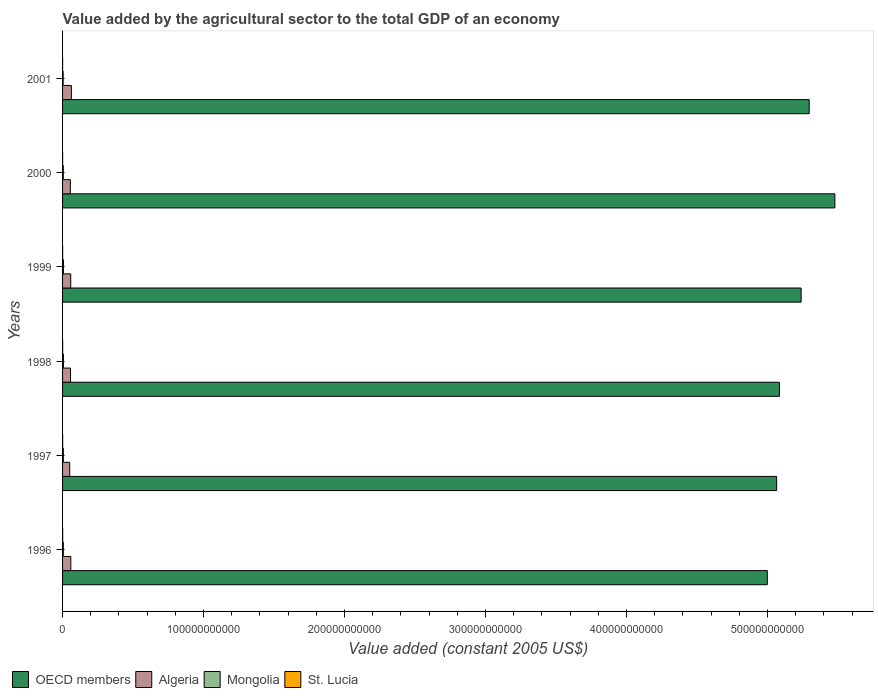How many bars are there on the 1st tick from the top?
Keep it short and to the point. 4. How many bars are there on the 4th tick from the bottom?
Provide a succinct answer. 4. What is the label of the 6th group of bars from the top?
Your answer should be very brief. 1996. What is the value added by the agricultural sector in OECD members in 1996?
Your answer should be compact. 5.00e+11. Across all years, what is the maximum value added by the agricultural sector in St. Lucia?
Your response must be concise. 8.23e+07. Across all years, what is the minimum value added by the agricultural sector in St. Lucia?
Give a very brief answer. 3.62e+07. What is the total value added by the agricultural sector in Algeria in the graph?
Your response must be concise. 3.41e+1. What is the difference between the value added by the agricultural sector in St. Lucia in 1997 and that in 2001?
Offer a terse response. 3.11e+07. What is the difference between the value added by the agricultural sector in Algeria in 1998 and the value added by the agricultural sector in Mongolia in 2001?
Keep it short and to the point. 5.23e+09. What is the average value added by the agricultural sector in Mongolia per year?
Ensure brevity in your answer.  5.40e+08. In the year 2001, what is the difference between the value added by the agricultural sector in Mongolia and value added by the agricultural sector in OECD members?
Ensure brevity in your answer.  -5.29e+11. In how many years, is the value added by the agricultural sector in Algeria greater than 440000000000 US$?
Your answer should be very brief. 0. What is the ratio of the value added by the agricultural sector in Algeria in 1998 to that in 1999?
Provide a short and direct response. 0.97. Is the difference between the value added by the agricultural sector in Mongolia in 1997 and 1999 greater than the difference between the value added by the agricultural sector in OECD members in 1997 and 1999?
Your answer should be compact. Yes. What is the difference between the highest and the second highest value added by the agricultural sector in St. Lucia?
Your answer should be very brief. 1.50e+07. What is the difference between the highest and the lowest value added by the agricultural sector in St. Lucia?
Your response must be concise. 4.61e+07. Is the sum of the value added by the agricultural sector in Algeria in 1996 and 1998 greater than the maximum value added by the agricultural sector in OECD members across all years?
Ensure brevity in your answer.  No. Is it the case that in every year, the sum of the value added by the agricultural sector in Mongolia and value added by the agricultural sector in Algeria is greater than the sum of value added by the agricultural sector in OECD members and value added by the agricultural sector in St. Lucia?
Provide a succinct answer. No. What does the 4th bar from the top in 1997 represents?
Ensure brevity in your answer.  OECD members. How many bars are there?
Make the answer very short. 24. Are all the bars in the graph horizontal?
Offer a very short reply. Yes. What is the difference between two consecutive major ticks on the X-axis?
Make the answer very short. 1.00e+11. Does the graph contain any zero values?
Your answer should be very brief. No. How many legend labels are there?
Make the answer very short. 4. How are the legend labels stacked?
Provide a short and direct response. Horizontal. What is the title of the graph?
Make the answer very short. Value added by the agricultural sector to the total GDP of an economy. Does "Trinidad and Tobago" appear as one of the legend labels in the graph?
Give a very brief answer. No. What is the label or title of the X-axis?
Provide a short and direct response. Value added (constant 2005 US$). What is the label or title of the Y-axis?
Keep it short and to the point. Years. What is the Value added (constant 2005 US$) in OECD members in 1996?
Your answer should be compact. 5.00e+11. What is the Value added (constant 2005 US$) in Algeria in 1996?
Your answer should be compact. 5.85e+09. What is the Value added (constant 2005 US$) in Mongolia in 1996?
Give a very brief answer. 5.42e+08. What is the Value added (constant 2005 US$) of St. Lucia in 1996?
Give a very brief answer. 8.23e+07. What is the Value added (constant 2005 US$) in OECD members in 1997?
Provide a succinct answer. 5.06e+11. What is the Value added (constant 2005 US$) in Algeria in 1997?
Give a very brief answer. 5.06e+09. What is the Value added (constant 2005 US$) in Mongolia in 1997?
Give a very brief answer. 5.66e+08. What is the Value added (constant 2005 US$) in St. Lucia in 1997?
Give a very brief answer. 6.73e+07. What is the Value added (constant 2005 US$) in OECD members in 1998?
Ensure brevity in your answer.  5.08e+11. What is the Value added (constant 2005 US$) in Algeria in 1998?
Make the answer very short. 5.64e+09. What is the Value added (constant 2005 US$) in Mongolia in 1998?
Offer a terse response. 5.95e+08. What is the Value added (constant 2005 US$) in St. Lucia in 1998?
Keep it short and to the point. 6.65e+07. What is the Value added (constant 2005 US$) of OECD members in 1999?
Keep it short and to the point. 5.24e+11. What is the Value added (constant 2005 US$) of Algeria in 1999?
Ensure brevity in your answer.  5.79e+09. What is the Value added (constant 2005 US$) in Mongolia in 1999?
Keep it short and to the point. 6.12e+08. What is the Value added (constant 2005 US$) in St. Lucia in 1999?
Give a very brief answer. 5.66e+07. What is the Value added (constant 2005 US$) of OECD members in 2000?
Your answer should be compact. 5.48e+11. What is the Value added (constant 2005 US$) in Algeria in 2000?
Give a very brief answer. 5.50e+09. What is the Value added (constant 2005 US$) of Mongolia in 2000?
Provide a short and direct response. 5.12e+08. What is the Value added (constant 2005 US$) in St. Lucia in 2000?
Make the answer very short. 4.70e+07. What is the Value added (constant 2005 US$) in OECD members in 2001?
Keep it short and to the point. 5.30e+11. What is the Value added (constant 2005 US$) in Algeria in 2001?
Ensure brevity in your answer.  6.23e+09. What is the Value added (constant 2005 US$) in Mongolia in 2001?
Provide a short and direct response. 4.14e+08. What is the Value added (constant 2005 US$) of St. Lucia in 2001?
Provide a succinct answer. 3.62e+07. Across all years, what is the maximum Value added (constant 2005 US$) in OECD members?
Your answer should be compact. 5.48e+11. Across all years, what is the maximum Value added (constant 2005 US$) in Algeria?
Provide a short and direct response. 6.23e+09. Across all years, what is the maximum Value added (constant 2005 US$) in Mongolia?
Make the answer very short. 6.12e+08. Across all years, what is the maximum Value added (constant 2005 US$) of St. Lucia?
Give a very brief answer. 8.23e+07. Across all years, what is the minimum Value added (constant 2005 US$) of OECD members?
Your answer should be compact. 5.00e+11. Across all years, what is the minimum Value added (constant 2005 US$) in Algeria?
Make the answer very short. 5.06e+09. Across all years, what is the minimum Value added (constant 2005 US$) of Mongolia?
Keep it short and to the point. 4.14e+08. Across all years, what is the minimum Value added (constant 2005 US$) of St. Lucia?
Keep it short and to the point. 3.62e+07. What is the total Value added (constant 2005 US$) in OECD members in the graph?
Provide a short and direct response. 3.12e+12. What is the total Value added (constant 2005 US$) in Algeria in the graph?
Offer a very short reply. 3.41e+1. What is the total Value added (constant 2005 US$) of Mongolia in the graph?
Offer a terse response. 3.24e+09. What is the total Value added (constant 2005 US$) in St. Lucia in the graph?
Your answer should be compact. 3.56e+08. What is the difference between the Value added (constant 2005 US$) of OECD members in 1996 and that in 1997?
Keep it short and to the point. -6.63e+09. What is the difference between the Value added (constant 2005 US$) in Algeria in 1996 and that in 1997?
Give a very brief answer. 7.87e+08. What is the difference between the Value added (constant 2005 US$) of Mongolia in 1996 and that in 1997?
Give a very brief answer. -2.40e+07. What is the difference between the Value added (constant 2005 US$) of St. Lucia in 1996 and that in 1997?
Give a very brief answer. 1.50e+07. What is the difference between the Value added (constant 2005 US$) in OECD members in 1996 and that in 1998?
Provide a short and direct response. -8.59e+09. What is the difference between the Value added (constant 2005 US$) in Algeria in 1996 and that in 1998?
Keep it short and to the point. 2.10e+08. What is the difference between the Value added (constant 2005 US$) of Mongolia in 1996 and that in 1998?
Give a very brief answer. -5.32e+07. What is the difference between the Value added (constant 2005 US$) of St. Lucia in 1996 and that in 1998?
Provide a short and direct response. 1.58e+07. What is the difference between the Value added (constant 2005 US$) in OECD members in 1996 and that in 1999?
Offer a terse response. -2.40e+1. What is the difference between the Value added (constant 2005 US$) in Algeria in 1996 and that in 1999?
Keep it short and to the point. 5.73e+07. What is the difference between the Value added (constant 2005 US$) of Mongolia in 1996 and that in 1999?
Provide a succinct answer. -7.03e+07. What is the difference between the Value added (constant 2005 US$) of St. Lucia in 1996 and that in 1999?
Keep it short and to the point. 2.57e+07. What is the difference between the Value added (constant 2005 US$) in OECD members in 1996 and that in 2000?
Make the answer very short. -4.79e+1. What is the difference between the Value added (constant 2005 US$) in Algeria in 1996 and that in 2000?
Your answer should be compact. 3.47e+08. What is the difference between the Value added (constant 2005 US$) of Mongolia in 1996 and that in 2000?
Ensure brevity in your answer.  2.97e+07. What is the difference between the Value added (constant 2005 US$) in St. Lucia in 1996 and that in 2000?
Offer a very short reply. 3.53e+07. What is the difference between the Value added (constant 2005 US$) of OECD members in 1996 and that in 2001?
Provide a succinct answer. -2.97e+1. What is the difference between the Value added (constant 2005 US$) in Algeria in 1996 and that in 2001?
Give a very brief answer. -3.84e+08. What is the difference between the Value added (constant 2005 US$) of Mongolia in 1996 and that in 2001?
Ensure brevity in your answer.  1.28e+08. What is the difference between the Value added (constant 2005 US$) of St. Lucia in 1996 and that in 2001?
Offer a terse response. 4.61e+07. What is the difference between the Value added (constant 2005 US$) of OECD members in 1997 and that in 1998?
Make the answer very short. -1.96e+09. What is the difference between the Value added (constant 2005 US$) of Algeria in 1997 and that in 1998?
Your answer should be compact. -5.77e+08. What is the difference between the Value added (constant 2005 US$) in Mongolia in 1997 and that in 1998?
Your response must be concise. -2.92e+07. What is the difference between the Value added (constant 2005 US$) in St. Lucia in 1997 and that in 1998?
Offer a terse response. 8.07e+05. What is the difference between the Value added (constant 2005 US$) of OECD members in 1997 and that in 1999?
Provide a succinct answer. -1.74e+1. What is the difference between the Value added (constant 2005 US$) of Algeria in 1997 and that in 1999?
Provide a short and direct response. -7.30e+08. What is the difference between the Value added (constant 2005 US$) in Mongolia in 1997 and that in 1999?
Keep it short and to the point. -4.63e+07. What is the difference between the Value added (constant 2005 US$) in St. Lucia in 1997 and that in 1999?
Keep it short and to the point. 1.07e+07. What is the difference between the Value added (constant 2005 US$) in OECD members in 1997 and that in 2000?
Provide a short and direct response. -4.13e+1. What is the difference between the Value added (constant 2005 US$) in Algeria in 1997 and that in 2000?
Make the answer very short. -4.40e+08. What is the difference between the Value added (constant 2005 US$) in Mongolia in 1997 and that in 2000?
Offer a terse response. 5.37e+07. What is the difference between the Value added (constant 2005 US$) in St. Lucia in 1997 and that in 2000?
Your answer should be compact. 2.03e+07. What is the difference between the Value added (constant 2005 US$) in OECD members in 1997 and that in 2001?
Ensure brevity in your answer.  -2.31e+1. What is the difference between the Value added (constant 2005 US$) in Algeria in 1997 and that in 2001?
Your answer should be compact. -1.17e+09. What is the difference between the Value added (constant 2005 US$) of Mongolia in 1997 and that in 2001?
Offer a terse response. 1.52e+08. What is the difference between the Value added (constant 2005 US$) of St. Lucia in 1997 and that in 2001?
Keep it short and to the point. 3.11e+07. What is the difference between the Value added (constant 2005 US$) in OECD members in 1998 and that in 1999?
Provide a short and direct response. -1.54e+1. What is the difference between the Value added (constant 2005 US$) in Algeria in 1998 and that in 1999?
Provide a succinct answer. -1.52e+08. What is the difference between the Value added (constant 2005 US$) in Mongolia in 1998 and that in 1999?
Provide a succinct answer. -1.70e+07. What is the difference between the Value added (constant 2005 US$) of St. Lucia in 1998 and that in 1999?
Your answer should be very brief. 9.93e+06. What is the difference between the Value added (constant 2005 US$) of OECD members in 1998 and that in 2000?
Provide a succinct answer. -3.93e+1. What is the difference between the Value added (constant 2005 US$) of Algeria in 1998 and that in 2000?
Provide a short and direct response. 1.37e+08. What is the difference between the Value added (constant 2005 US$) in Mongolia in 1998 and that in 2000?
Give a very brief answer. 8.29e+07. What is the difference between the Value added (constant 2005 US$) of St. Lucia in 1998 and that in 2000?
Your response must be concise. 1.95e+07. What is the difference between the Value added (constant 2005 US$) of OECD members in 1998 and that in 2001?
Offer a terse response. -2.11e+1. What is the difference between the Value added (constant 2005 US$) in Algeria in 1998 and that in 2001?
Keep it short and to the point. -5.93e+08. What is the difference between the Value added (constant 2005 US$) in Mongolia in 1998 and that in 2001?
Make the answer very short. 1.81e+08. What is the difference between the Value added (constant 2005 US$) in St. Lucia in 1998 and that in 2001?
Give a very brief answer. 3.03e+07. What is the difference between the Value added (constant 2005 US$) in OECD members in 1999 and that in 2000?
Provide a short and direct response. -2.39e+1. What is the difference between the Value added (constant 2005 US$) in Algeria in 1999 and that in 2000?
Your answer should be very brief. 2.90e+08. What is the difference between the Value added (constant 2005 US$) in Mongolia in 1999 and that in 2000?
Keep it short and to the point. 1.00e+08. What is the difference between the Value added (constant 2005 US$) of St. Lucia in 1999 and that in 2000?
Your answer should be very brief. 9.55e+06. What is the difference between the Value added (constant 2005 US$) in OECD members in 1999 and that in 2001?
Offer a very short reply. -5.73e+09. What is the difference between the Value added (constant 2005 US$) of Algeria in 1999 and that in 2001?
Keep it short and to the point. -4.41e+08. What is the difference between the Value added (constant 2005 US$) of Mongolia in 1999 and that in 2001?
Offer a very short reply. 1.98e+08. What is the difference between the Value added (constant 2005 US$) of St. Lucia in 1999 and that in 2001?
Give a very brief answer. 2.04e+07. What is the difference between the Value added (constant 2005 US$) in OECD members in 2000 and that in 2001?
Your answer should be very brief. 1.82e+1. What is the difference between the Value added (constant 2005 US$) in Algeria in 2000 and that in 2001?
Provide a succinct answer. -7.31e+08. What is the difference between the Value added (constant 2005 US$) in Mongolia in 2000 and that in 2001?
Offer a very short reply. 9.81e+07. What is the difference between the Value added (constant 2005 US$) of St. Lucia in 2000 and that in 2001?
Ensure brevity in your answer.  1.08e+07. What is the difference between the Value added (constant 2005 US$) of OECD members in 1996 and the Value added (constant 2005 US$) of Algeria in 1997?
Give a very brief answer. 4.95e+11. What is the difference between the Value added (constant 2005 US$) of OECD members in 1996 and the Value added (constant 2005 US$) of Mongolia in 1997?
Keep it short and to the point. 4.99e+11. What is the difference between the Value added (constant 2005 US$) of OECD members in 1996 and the Value added (constant 2005 US$) of St. Lucia in 1997?
Provide a short and direct response. 5.00e+11. What is the difference between the Value added (constant 2005 US$) in Algeria in 1996 and the Value added (constant 2005 US$) in Mongolia in 1997?
Provide a succinct answer. 5.29e+09. What is the difference between the Value added (constant 2005 US$) of Algeria in 1996 and the Value added (constant 2005 US$) of St. Lucia in 1997?
Provide a short and direct response. 5.78e+09. What is the difference between the Value added (constant 2005 US$) in Mongolia in 1996 and the Value added (constant 2005 US$) in St. Lucia in 1997?
Offer a terse response. 4.75e+08. What is the difference between the Value added (constant 2005 US$) of OECD members in 1996 and the Value added (constant 2005 US$) of Algeria in 1998?
Make the answer very short. 4.94e+11. What is the difference between the Value added (constant 2005 US$) of OECD members in 1996 and the Value added (constant 2005 US$) of Mongolia in 1998?
Give a very brief answer. 4.99e+11. What is the difference between the Value added (constant 2005 US$) of OECD members in 1996 and the Value added (constant 2005 US$) of St. Lucia in 1998?
Provide a short and direct response. 5.00e+11. What is the difference between the Value added (constant 2005 US$) in Algeria in 1996 and the Value added (constant 2005 US$) in Mongolia in 1998?
Keep it short and to the point. 5.26e+09. What is the difference between the Value added (constant 2005 US$) in Algeria in 1996 and the Value added (constant 2005 US$) in St. Lucia in 1998?
Give a very brief answer. 5.78e+09. What is the difference between the Value added (constant 2005 US$) of Mongolia in 1996 and the Value added (constant 2005 US$) of St. Lucia in 1998?
Ensure brevity in your answer.  4.75e+08. What is the difference between the Value added (constant 2005 US$) of OECD members in 1996 and the Value added (constant 2005 US$) of Algeria in 1999?
Give a very brief answer. 4.94e+11. What is the difference between the Value added (constant 2005 US$) of OECD members in 1996 and the Value added (constant 2005 US$) of Mongolia in 1999?
Give a very brief answer. 4.99e+11. What is the difference between the Value added (constant 2005 US$) in OECD members in 1996 and the Value added (constant 2005 US$) in St. Lucia in 1999?
Keep it short and to the point. 5.00e+11. What is the difference between the Value added (constant 2005 US$) in Algeria in 1996 and the Value added (constant 2005 US$) in Mongolia in 1999?
Offer a terse response. 5.24e+09. What is the difference between the Value added (constant 2005 US$) of Algeria in 1996 and the Value added (constant 2005 US$) of St. Lucia in 1999?
Offer a terse response. 5.79e+09. What is the difference between the Value added (constant 2005 US$) of Mongolia in 1996 and the Value added (constant 2005 US$) of St. Lucia in 1999?
Offer a very short reply. 4.85e+08. What is the difference between the Value added (constant 2005 US$) of OECD members in 1996 and the Value added (constant 2005 US$) of Algeria in 2000?
Offer a terse response. 4.94e+11. What is the difference between the Value added (constant 2005 US$) of OECD members in 1996 and the Value added (constant 2005 US$) of Mongolia in 2000?
Provide a short and direct response. 4.99e+11. What is the difference between the Value added (constant 2005 US$) of OECD members in 1996 and the Value added (constant 2005 US$) of St. Lucia in 2000?
Offer a very short reply. 5.00e+11. What is the difference between the Value added (constant 2005 US$) in Algeria in 1996 and the Value added (constant 2005 US$) in Mongolia in 2000?
Your answer should be very brief. 5.34e+09. What is the difference between the Value added (constant 2005 US$) of Algeria in 1996 and the Value added (constant 2005 US$) of St. Lucia in 2000?
Your response must be concise. 5.80e+09. What is the difference between the Value added (constant 2005 US$) of Mongolia in 1996 and the Value added (constant 2005 US$) of St. Lucia in 2000?
Offer a very short reply. 4.95e+08. What is the difference between the Value added (constant 2005 US$) in OECD members in 1996 and the Value added (constant 2005 US$) in Algeria in 2001?
Offer a very short reply. 4.94e+11. What is the difference between the Value added (constant 2005 US$) of OECD members in 1996 and the Value added (constant 2005 US$) of Mongolia in 2001?
Offer a terse response. 4.99e+11. What is the difference between the Value added (constant 2005 US$) in OECD members in 1996 and the Value added (constant 2005 US$) in St. Lucia in 2001?
Provide a succinct answer. 5.00e+11. What is the difference between the Value added (constant 2005 US$) in Algeria in 1996 and the Value added (constant 2005 US$) in Mongolia in 2001?
Give a very brief answer. 5.44e+09. What is the difference between the Value added (constant 2005 US$) of Algeria in 1996 and the Value added (constant 2005 US$) of St. Lucia in 2001?
Your response must be concise. 5.82e+09. What is the difference between the Value added (constant 2005 US$) in Mongolia in 1996 and the Value added (constant 2005 US$) in St. Lucia in 2001?
Offer a very short reply. 5.06e+08. What is the difference between the Value added (constant 2005 US$) in OECD members in 1997 and the Value added (constant 2005 US$) in Algeria in 1998?
Ensure brevity in your answer.  5.01e+11. What is the difference between the Value added (constant 2005 US$) of OECD members in 1997 and the Value added (constant 2005 US$) of Mongolia in 1998?
Ensure brevity in your answer.  5.06e+11. What is the difference between the Value added (constant 2005 US$) of OECD members in 1997 and the Value added (constant 2005 US$) of St. Lucia in 1998?
Provide a short and direct response. 5.06e+11. What is the difference between the Value added (constant 2005 US$) of Algeria in 1997 and the Value added (constant 2005 US$) of Mongolia in 1998?
Offer a very short reply. 4.47e+09. What is the difference between the Value added (constant 2005 US$) of Algeria in 1997 and the Value added (constant 2005 US$) of St. Lucia in 1998?
Provide a succinct answer. 5.00e+09. What is the difference between the Value added (constant 2005 US$) in Mongolia in 1997 and the Value added (constant 2005 US$) in St. Lucia in 1998?
Provide a succinct answer. 4.99e+08. What is the difference between the Value added (constant 2005 US$) in OECD members in 1997 and the Value added (constant 2005 US$) in Algeria in 1999?
Keep it short and to the point. 5.01e+11. What is the difference between the Value added (constant 2005 US$) of OECD members in 1997 and the Value added (constant 2005 US$) of Mongolia in 1999?
Ensure brevity in your answer.  5.06e+11. What is the difference between the Value added (constant 2005 US$) in OECD members in 1997 and the Value added (constant 2005 US$) in St. Lucia in 1999?
Give a very brief answer. 5.06e+11. What is the difference between the Value added (constant 2005 US$) of Algeria in 1997 and the Value added (constant 2005 US$) of Mongolia in 1999?
Provide a short and direct response. 4.45e+09. What is the difference between the Value added (constant 2005 US$) of Algeria in 1997 and the Value added (constant 2005 US$) of St. Lucia in 1999?
Your answer should be very brief. 5.01e+09. What is the difference between the Value added (constant 2005 US$) of Mongolia in 1997 and the Value added (constant 2005 US$) of St. Lucia in 1999?
Your answer should be very brief. 5.09e+08. What is the difference between the Value added (constant 2005 US$) in OECD members in 1997 and the Value added (constant 2005 US$) in Algeria in 2000?
Provide a short and direct response. 5.01e+11. What is the difference between the Value added (constant 2005 US$) in OECD members in 1997 and the Value added (constant 2005 US$) in Mongolia in 2000?
Your response must be concise. 5.06e+11. What is the difference between the Value added (constant 2005 US$) in OECD members in 1997 and the Value added (constant 2005 US$) in St. Lucia in 2000?
Give a very brief answer. 5.06e+11. What is the difference between the Value added (constant 2005 US$) of Algeria in 1997 and the Value added (constant 2005 US$) of Mongolia in 2000?
Give a very brief answer. 4.55e+09. What is the difference between the Value added (constant 2005 US$) in Algeria in 1997 and the Value added (constant 2005 US$) in St. Lucia in 2000?
Offer a very short reply. 5.02e+09. What is the difference between the Value added (constant 2005 US$) in Mongolia in 1997 and the Value added (constant 2005 US$) in St. Lucia in 2000?
Give a very brief answer. 5.19e+08. What is the difference between the Value added (constant 2005 US$) in OECD members in 1997 and the Value added (constant 2005 US$) in Algeria in 2001?
Your answer should be compact. 5.00e+11. What is the difference between the Value added (constant 2005 US$) in OECD members in 1997 and the Value added (constant 2005 US$) in Mongolia in 2001?
Keep it short and to the point. 5.06e+11. What is the difference between the Value added (constant 2005 US$) in OECD members in 1997 and the Value added (constant 2005 US$) in St. Lucia in 2001?
Ensure brevity in your answer.  5.06e+11. What is the difference between the Value added (constant 2005 US$) of Algeria in 1997 and the Value added (constant 2005 US$) of Mongolia in 2001?
Keep it short and to the point. 4.65e+09. What is the difference between the Value added (constant 2005 US$) of Algeria in 1997 and the Value added (constant 2005 US$) of St. Lucia in 2001?
Provide a short and direct response. 5.03e+09. What is the difference between the Value added (constant 2005 US$) in Mongolia in 1997 and the Value added (constant 2005 US$) in St. Lucia in 2001?
Offer a terse response. 5.30e+08. What is the difference between the Value added (constant 2005 US$) of OECD members in 1998 and the Value added (constant 2005 US$) of Algeria in 1999?
Make the answer very short. 5.03e+11. What is the difference between the Value added (constant 2005 US$) of OECD members in 1998 and the Value added (constant 2005 US$) of Mongolia in 1999?
Your response must be concise. 5.08e+11. What is the difference between the Value added (constant 2005 US$) of OECD members in 1998 and the Value added (constant 2005 US$) of St. Lucia in 1999?
Your response must be concise. 5.08e+11. What is the difference between the Value added (constant 2005 US$) in Algeria in 1998 and the Value added (constant 2005 US$) in Mongolia in 1999?
Your response must be concise. 5.03e+09. What is the difference between the Value added (constant 2005 US$) of Algeria in 1998 and the Value added (constant 2005 US$) of St. Lucia in 1999?
Your response must be concise. 5.59e+09. What is the difference between the Value added (constant 2005 US$) of Mongolia in 1998 and the Value added (constant 2005 US$) of St. Lucia in 1999?
Your answer should be very brief. 5.39e+08. What is the difference between the Value added (constant 2005 US$) in OECD members in 1998 and the Value added (constant 2005 US$) in Algeria in 2000?
Your answer should be very brief. 5.03e+11. What is the difference between the Value added (constant 2005 US$) of OECD members in 1998 and the Value added (constant 2005 US$) of Mongolia in 2000?
Provide a short and direct response. 5.08e+11. What is the difference between the Value added (constant 2005 US$) of OECD members in 1998 and the Value added (constant 2005 US$) of St. Lucia in 2000?
Ensure brevity in your answer.  5.08e+11. What is the difference between the Value added (constant 2005 US$) of Algeria in 1998 and the Value added (constant 2005 US$) of Mongolia in 2000?
Your response must be concise. 5.13e+09. What is the difference between the Value added (constant 2005 US$) of Algeria in 1998 and the Value added (constant 2005 US$) of St. Lucia in 2000?
Your response must be concise. 5.59e+09. What is the difference between the Value added (constant 2005 US$) in Mongolia in 1998 and the Value added (constant 2005 US$) in St. Lucia in 2000?
Keep it short and to the point. 5.48e+08. What is the difference between the Value added (constant 2005 US$) in OECD members in 1998 and the Value added (constant 2005 US$) in Algeria in 2001?
Offer a terse response. 5.02e+11. What is the difference between the Value added (constant 2005 US$) of OECD members in 1998 and the Value added (constant 2005 US$) of Mongolia in 2001?
Provide a succinct answer. 5.08e+11. What is the difference between the Value added (constant 2005 US$) in OECD members in 1998 and the Value added (constant 2005 US$) in St. Lucia in 2001?
Offer a terse response. 5.08e+11. What is the difference between the Value added (constant 2005 US$) in Algeria in 1998 and the Value added (constant 2005 US$) in Mongolia in 2001?
Give a very brief answer. 5.23e+09. What is the difference between the Value added (constant 2005 US$) of Algeria in 1998 and the Value added (constant 2005 US$) of St. Lucia in 2001?
Make the answer very short. 5.61e+09. What is the difference between the Value added (constant 2005 US$) in Mongolia in 1998 and the Value added (constant 2005 US$) in St. Lucia in 2001?
Your answer should be very brief. 5.59e+08. What is the difference between the Value added (constant 2005 US$) of OECD members in 1999 and the Value added (constant 2005 US$) of Algeria in 2000?
Make the answer very short. 5.18e+11. What is the difference between the Value added (constant 2005 US$) of OECD members in 1999 and the Value added (constant 2005 US$) of Mongolia in 2000?
Keep it short and to the point. 5.23e+11. What is the difference between the Value added (constant 2005 US$) in OECD members in 1999 and the Value added (constant 2005 US$) in St. Lucia in 2000?
Offer a terse response. 5.24e+11. What is the difference between the Value added (constant 2005 US$) in Algeria in 1999 and the Value added (constant 2005 US$) in Mongolia in 2000?
Make the answer very short. 5.28e+09. What is the difference between the Value added (constant 2005 US$) of Algeria in 1999 and the Value added (constant 2005 US$) of St. Lucia in 2000?
Make the answer very short. 5.75e+09. What is the difference between the Value added (constant 2005 US$) of Mongolia in 1999 and the Value added (constant 2005 US$) of St. Lucia in 2000?
Your answer should be very brief. 5.65e+08. What is the difference between the Value added (constant 2005 US$) of OECD members in 1999 and the Value added (constant 2005 US$) of Algeria in 2001?
Your response must be concise. 5.18e+11. What is the difference between the Value added (constant 2005 US$) of OECD members in 1999 and the Value added (constant 2005 US$) of Mongolia in 2001?
Your answer should be very brief. 5.23e+11. What is the difference between the Value added (constant 2005 US$) in OECD members in 1999 and the Value added (constant 2005 US$) in St. Lucia in 2001?
Ensure brevity in your answer.  5.24e+11. What is the difference between the Value added (constant 2005 US$) of Algeria in 1999 and the Value added (constant 2005 US$) of Mongolia in 2001?
Your answer should be very brief. 5.38e+09. What is the difference between the Value added (constant 2005 US$) in Algeria in 1999 and the Value added (constant 2005 US$) in St. Lucia in 2001?
Ensure brevity in your answer.  5.76e+09. What is the difference between the Value added (constant 2005 US$) of Mongolia in 1999 and the Value added (constant 2005 US$) of St. Lucia in 2001?
Your answer should be compact. 5.76e+08. What is the difference between the Value added (constant 2005 US$) in OECD members in 2000 and the Value added (constant 2005 US$) in Algeria in 2001?
Give a very brief answer. 5.42e+11. What is the difference between the Value added (constant 2005 US$) in OECD members in 2000 and the Value added (constant 2005 US$) in Mongolia in 2001?
Offer a terse response. 5.47e+11. What is the difference between the Value added (constant 2005 US$) of OECD members in 2000 and the Value added (constant 2005 US$) of St. Lucia in 2001?
Ensure brevity in your answer.  5.48e+11. What is the difference between the Value added (constant 2005 US$) in Algeria in 2000 and the Value added (constant 2005 US$) in Mongolia in 2001?
Make the answer very short. 5.09e+09. What is the difference between the Value added (constant 2005 US$) in Algeria in 2000 and the Value added (constant 2005 US$) in St. Lucia in 2001?
Keep it short and to the point. 5.47e+09. What is the difference between the Value added (constant 2005 US$) of Mongolia in 2000 and the Value added (constant 2005 US$) of St. Lucia in 2001?
Your response must be concise. 4.76e+08. What is the average Value added (constant 2005 US$) of OECD members per year?
Offer a very short reply. 5.19e+11. What is the average Value added (constant 2005 US$) of Algeria per year?
Offer a very short reply. 5.68e+09. What is the average Value added (constant 2005 US$) in Mongolia per year?
Keep it short and to the point. 5.40e+08. What is the average Value added (constant 2005 US$) in St. Lucia per year?
Keep it short and to the point. 5.93e+07. In the year 1996, what is the difference between the Value added (constant 2005 US$) in OECD members and Value added (constant 2005 US$) in Algeria?
Your answer should be compact. 4.94e+11. In the year 1996, what is the difference between the Value added (constant 2005 US$) in OECD members and Value added (constant 2005 US$) in Mongolia?
Ensure brevity in your answer.  4.99e+11. In the year 1996, what is the difference between the Value added (constant 2005 US$) of OECD members and Value added (constant 2005 US$) of St. Lucia?
Ensure brevity in your answer.  5.00e+11. In the year 1996, what is the difference between the Value added (constant 2005 US$) in Algeria and Value added (constant 2005 US$) in Mongolia?
Your answer should be very brief. 5.31e+09. In the year 1996, what is the difference between the Value added (constant 2005 US$) in Algeria and Value added (constant 2005 US$) in St. Lucia?
Your answer should be compact. 5.77e+09. In the year 1996, what is the difference between the Value added (constant 2005 US$) of Mongolia and Value added (constant 2005 US$) of St. Lucia?
Keep it short and to the point. 4.60e+08. In the year 1997, what is the difference between the Value added (constant 2005 US$) of OECD members and Value added (constant 2005 US$) of Algeria?
Give a very brief answer. 5.01e+11. In the year 1997, what is the difference between the Value added (constant 2005 US$) in OECD members and Value added (constant 2005 US$) in Mongolia?
Provide a succinct answer. 5.06e+11. In the year 1997, what is the difference between the Value added (constant 2005 US$) in OECD members and Value added (constant 2005 US$) in St. Lucia?
Offer a terse response. 5.06e+11. In the year 1997, what is the difference between the Value added (constant 2005 US$) of Algeria and Value added (constant 2005 US$) of Mongolia?
Make the answer very short. 4.50e+09. In the year 1997, what is the difference between the Value added (constant 2005 US$) of Algeria and Value added (constant 2005 US$) of St. Lucia?
Your answer should be compact. 5.00e+09. In the year 1997, what is the difference between the Value added (constant 2005 US$) in Mongolia and Value added (constant 2005 US$) in St. Lucia?
Provide a short and direct response. 4.99e+08. In the year 1998, what is the difference between the Value added (constant 2005 US$) in OECD members and Value added (constant 2005 US$) in Algeria?
Your answer should be very brief. 5.03e+11. In the year 1998, what is the difference between the Value added (constant 2005 US$) of OECD members and Value added (constant 2005 US$) of Mongolia?
Provide a short and direct response. 5.08e+11. In the year 1998, what is the difference between the Value added (constant 2005 US$) of OECD members and Value added (constant 2005 US$) of St. Lucia?
Provide a short and direct response. 5.08e+11. In the year 1998, what is the difference between the Value added (constant 2005 US$) of Algeria and Value added (constant 2005 US$) of Mongolia?
Your answer should be very brief. 5.05e+09. In the year 1998, what is the difference between the Value added (constant 2005 US$) in Algeria and Value added (constant 2005 US$) in St. Lucia?
Offer a terse response. 5.58e+09. In the year 1998, what is the difference between the Value added (constant 2005 US$) in Mongolia and Value added (constant 2005 US$) in St. Lucia?
Your response must be concise. 5.29e+08. In the year 1999, what is the difference between the Value added (constant 2005 US$) in OECD members and Value added (constant 2005 US$) in Algeria?
Offer a terse response. 5.18e+11. In the year 1999, what is the difference between the Value added (constant 2005 US$) in OECD members and Value added (constant 2005 US$) in Mongolia?
Offer a terse response. 5.23e+11. In the year 1999, what is the difference between the Value added (constant 2005 US$) in OECD members and Value added (constant 2005 US$) in St. Lucia?
Provide a succinct answer. 5.24e+11. In the year 1999, what is the difference between the Value added (constant 2005 US$) of Algeria and Value added (constant 2005 US$) of Mongolia?
Your answer should be very brief. 5.18e+09. In the year 1999, what is the difference between the Value added (constant 2005 US$) in Algeria and Value added (constant 2005 US$) in St. Lucia?
Ensure brevity in your answer.  5.74e+09. In the year 1999, what is the difference between the Value added (constant 2005 US$) in Mongolia and Value added (constant 2005 US$) in St. Lucia?
Ensure brevity in your answer.  5.56e+08. In the year 2000, what is the difference between the Value added (constant 2005 US$) of OECD members and Value added (constant 2005 US$) of Algeria?
Your answer should be very brief. 5.42e+11. In the year 2000, what is the difference between the Value added (constant 2005 US$) in OECD members and Value added (constant 2005 US$) in Mongolia?
Provide a succinct answer. 5.47e+11. In the year 2000, what is the difference between the Value added (constant 2005 US$) of OECD members and Value added (constant 2005 US$) of St. Lucia?
Make the answer very short. 5.48e+11. In the year 2000, what is the difference between the Value added (constant 2005 US$) of Algeria and Value added (constant 2005 US$) of Mongolia?
Give a very brief answer. 4.99e+09. In the year 2000, what is the difference between the Value added (constant 2005 US$) of Algeria and Value added (constant 2005 US$) of St. Lucia?
Your answer should be very brief. 5.46e+09. In the year 2000, what is the difference between the Value added (constant 2005 US$) in Mongolia and Value added (constant 2005 US$) in St. Lucia?
Your response must be concise. 4.65e+08. In the year 2001, what is the difference between the Value added (constant 2005 US$) of OECD members and Value added (constant 2005 US$) of Algeria?
Your response must be concise. 5.23e+11. In the year 2001, what is the difference between the Value added (constant 2005 US$) of OECD members and Value added (constant 2005 US$) of Mongolia?
Make the answer very short. 5.29e+11. In the year 2001, what is the difference between the Value added (constant 2005 US$) of OECD members and Value added (constant 2005 US$) of St. Lucia?
Your answer should be very brief. 5.30e+11. In the year 2001, what is the difference between the Value added (constant 2005 US$) of Algeria and Value added (constant 2005 US$) of Mongolia?
Provide a short and direct response. 5.82e+09. In the year 2001, what is the difference between the Value added (constant 2005 US$) in Algeria and Value added (constant 2005 US$) in St. Lucia?
Offer a very short reply. 6.20e+09. In the year 2001, what is the difference between the Value added (constant 2005 US$) in Mongolia and Value added (constant 2005 US$) in St. Lucia?
Offer a very short reply. 3.78e+08. What is the ratio of the Value added (constant 2005 US$) of OECD members in 1996 to that in 1997?
Give a very brief answer. 0.99. What is the ratio of the Value added (constant 2005 US$) of Algeria in 1996 to that in 1997?
Provide a succinct answer. 1.16. What is the ratio of the Value added (constant 2005 US$) in Mongolia in 1996 to that in 1997?
Make the answer very short. 0.96. What is the ratio of the Value added (constant 2005 US$) of St. Lucia in 1996 to that in 1997?
Your answer should be very brief. 1.22. What is the ratio of the Value added (constant 2005 US$) of OECD members in 1996 to that in 1998?
Your answer should be compact. 0.98. What is the ratio of the Value added (constant 2005 US$) in Algeria in 1996 to that in 1998?
Keep it short and to the point. 1.04. What is the ratio of the Value added (constant 2005 US$) of Mongolia in 1996 to that in 1998?
Provide a short and direct response. 0.91. What is the ratio of the Value added (constant 2005 US$) in St. Lucia in 1996 to that in 1998?
Your answer should be very brief. 1.24. What is the ratio of the Value added (constant 2005 US$) in OECD members in 1996 to that in 1999?
Your answer should be compact. 0.95. What is the ratio of the Value added (constant 2005 US$) in Algeria in 1996 to that in 1999?
Keep it short and to the point. 1.01. What is the ratio of the Value added (constant 2005 US$) in Mongolia in 1996 to that in 1999?
Keep it short and to the point. 0.89. What is the ratio of the Value added (constant 2005 US$) in St. Lucia in 1996 to that in 1999?
Your answer should be very brief. 1.45. What is the ratio of the Value added (constant 2005 US$) of OECD members in 1996 to that in 2000?
Give a very brief answer. 0.91. What is the ratio of the Value added (constant 2005 US$) of Algeria in 1996 to that in 2000?
Ensure brevity in your answer.  1.06. What is the ratio of the Value added (constant 2005 US$) in Mongolia in 1996 to that in 2000?
Your answer should be very brief. 1.06. What is the ratio of the Value added (constant 2005 US$) of St. Lucia in 1996 to that in 2000?
Give a very brief answer. 1.75. What is the ratio of the Value added (constant 2005 US$) of OECD members in 1996 to that in 2001?
Give a very brief answer. 0.94. What is the ratio of the Value added (constant 2005 US$) of Algeria in 1996 to that in 2001?
Offer a very short reply. 0.94. What is the ratio of the Value added (constant 2005 US$) of Mongolia in 1996 to that in 2001?
Give a very brief answer. 1.31. What is the ratio of the Value added (constant 2005 US$) in St. Lucia in 1996 to that in 2001?
Offer a very short reply. 2.27. What is the ratio of the Value added (constant 2005 US$) of OECD members in 1997 to that in 1998?
Offer a very short reply. 1. What is the ratio of the Value added (constant 2005 US$) of Algeria in 1997 to that in 1998?
Offer a very short reply. 0.9. What is the ratio of the Value added (constant 2005 US$) of Mongolia in 1997 to that in 1998?
Offer a very short reply. 0.95. What is the ratio of the Value added (constant 2005 US$) of St. Lucia in 1997 to that in 1998?
Ensure brevity in your answer.  1.01. What is the ratio of the Value added (constant 2005 US$) in OECD members in 1997 to that in 1999?
Your answer should be very brief. 0.97. What is the ratio of the Value added (constant 2005 US$) in Algeria in 1997 to that in 1999?
Make the answer very short. 0.87. What is the ratio of the Value added (constant 2005 US$) in Mongolia in 1997 to that in 1999?
Ensure brevity in your answer.  0.92. What is the ratio of the Value added (constant 2005 US$) of St. Lucia in 1997 to that in 1999?
Your answer should be compact. 1.19. What is the ratio of the Value added (constant 2005 US$) in OECD members in 1997 to that in 2000?
Keep it short and to the point. 0.92. What is the ratio of the Value added (constant 2005 US$) of Algeria in 1997 to that in 2000?
Provide a short and direct response. 0.92. What is the ratio of the Value added (constant 2005 US$) in Mongolia in 1997 to that in 2000?
Provide a short and direct response. 1.1. What is the ratio of the Value added (constant 2005 US$) of St. Lucia in 1997 to that in 2000?
Offer a terse response. 1.43. What is the ratio of the Value added (constant 2005 US$) of OECD members in 1997 to that in 2001?
Offer a terse response. 0.96. What is the ratio of the Value added (constant 2005 US$) in Algeria in 1997 to that in 2001?
Your response must be concise. 0.81. What is the ratio of the Value added (constant 2005 US$) of Mongolia in 1997 to that in 2001?
Offer a very short reply. 1.37. What is the ratio of the Value added (constant 2005 US$) of St. Lucia in 1997 to that in 2001?
Your answer should be compact. 1.86. What is the ratio of the Value added (constant 2005 US$) in OECD members in 1998 to that in 1999?
Give a very brief answer. 0.97. What is the ratio of the Value added (constant 2005 US$) of Algeria in 1998 to that in 1999?
Your response must be concise. 0.97. What is the ratio of the Value added (constant 2005 US$) of Mongolia in 1998 to that in 1999?
Your response must be concise. 0.97. What is the ratio of the Value added (constant 2005 US$) of St. Lucia in 1998 to that in 1999?
Make the answer very short. 1.18. What is the ratio of the Value added (constant 2005 US$) in OECD members in 1998 to that in 2000?
Provide a succinct answer. 0.93. What is the ratio of the Value added (constant 2005 US$) in Algeria in 1998 to that in 2000?
Provide a short and direct response. 1.02. What is the ratio of the Value added (constant 2005 US$) in Mongolia in 1998 to that in 2000?
Offer a very short reply. 1.16. What is the ratio of the Value added (constant 2005 US$) in St. Lucia in 1998 to that in 2000?
Make the answer very short. 1.41. What is the ratio of the Value added (constant 2005 US$) of OECD members in 1998 to that in 2001?
Your answer should be compact. 0.96. What is the ratio of the Value added (constant 2005 US$) in Algeria in 1998 to that in 2001?
Your answer should be very brief. 0.9. What is the ratio of the Value added (constant 2005 US$) in Mongolia in 1998 to that in 2001?
Your answer should be compact. 1.44. What is the ratio of the Value added (constant 2005 US$) of St. Lucia in 1998 to that in 2001?
Your response must be concise. 1.84. What is the ratio of the Value added (constant 2005 US$) of OECD members in 1999 to that in 2000?
Provide a succinct answer. 0.96. What is the ratio of the Value added (constant 2005 US$) in Algeria in 1999 to that in 2000?
Keep it short and to the point. 1.05. What is the ratio of the Value added (constant 2005 US$) in Mongolia in 1999 to that in 2000?
Your response must be concise. 1.2. What is the ratio of the Value added (constant 2005 US$) of St. Lucia in 1999 to that in 2000?
Your answer should be compact. 1.2. What is the ratio of the Value added (constant 2005 US$) of Algeria in 1999 to that in 2001?
Your response must be concise. 0.93. What is the ratio of the Value added (constant 2005 US$) of Mongolia in 1999 to that in 2001?
Offer a terse response. 1.48. What is the ratio of the Value added (constant 2005 US$) of St. Lucia in 1999 to that in 2001?
Provide a short and direct response. 1.56. What is the ratio of the Value added (constant 2005 US$) of OECD members in 2000 to that in 2001?
Provide a succinct answer. 1.03. What is the ratio of the Value added (constant 2005 US$) of Algeria in 2000 to that in 2001?
Provide a short and direct response. 0.88. What is the ratio of the Value added (constant 2005 US$) of Mongolia in 2000 to that in 2001?
Offer a terse response. 1.24. What is the ratio of the Value added (constant 2005 US$) of St. Lucia in 2000 to that in 2001?
Offer a very short reply. 1.3. What is the difference between the highest and the second highest Value added (constant 2005 US$) of OECD members?
Provide a short and direct response. 1.82e+1. What is the difference between the highest and the second highest Value added (constant 2005 US$) of Algeria?
Make the answer very short. 3.84e+08. What is the difference between the highest and the second highest Value added (constant 2005 US$) in Mongolia?
Give a very brief answer. 1.70e+07. What is the difference between the highest and the second highest Value added (constant 2005 US$) of St. Lucia?
Give a very brief answer. 1.50e+07. What is the difference between the highest and the lowest Value added (constant 2005 US$) in OECD members?
Your answer should be compact. 4.79e+1. What is the difference between the highest and the lowest Value added (constant 2005 US$) in Algeria?
Give a very brief answer. 1.17e+09. What is the difference between the highest and the lowest Value added (constant 2005 US$) in Mongolia?
Offer a very short reply. 1.98e+08. What is the difference between the highest and the lowest Value added (constant 2005 US$) of St. Lucia?
Keep it short and to the point. 4.61e+07. 